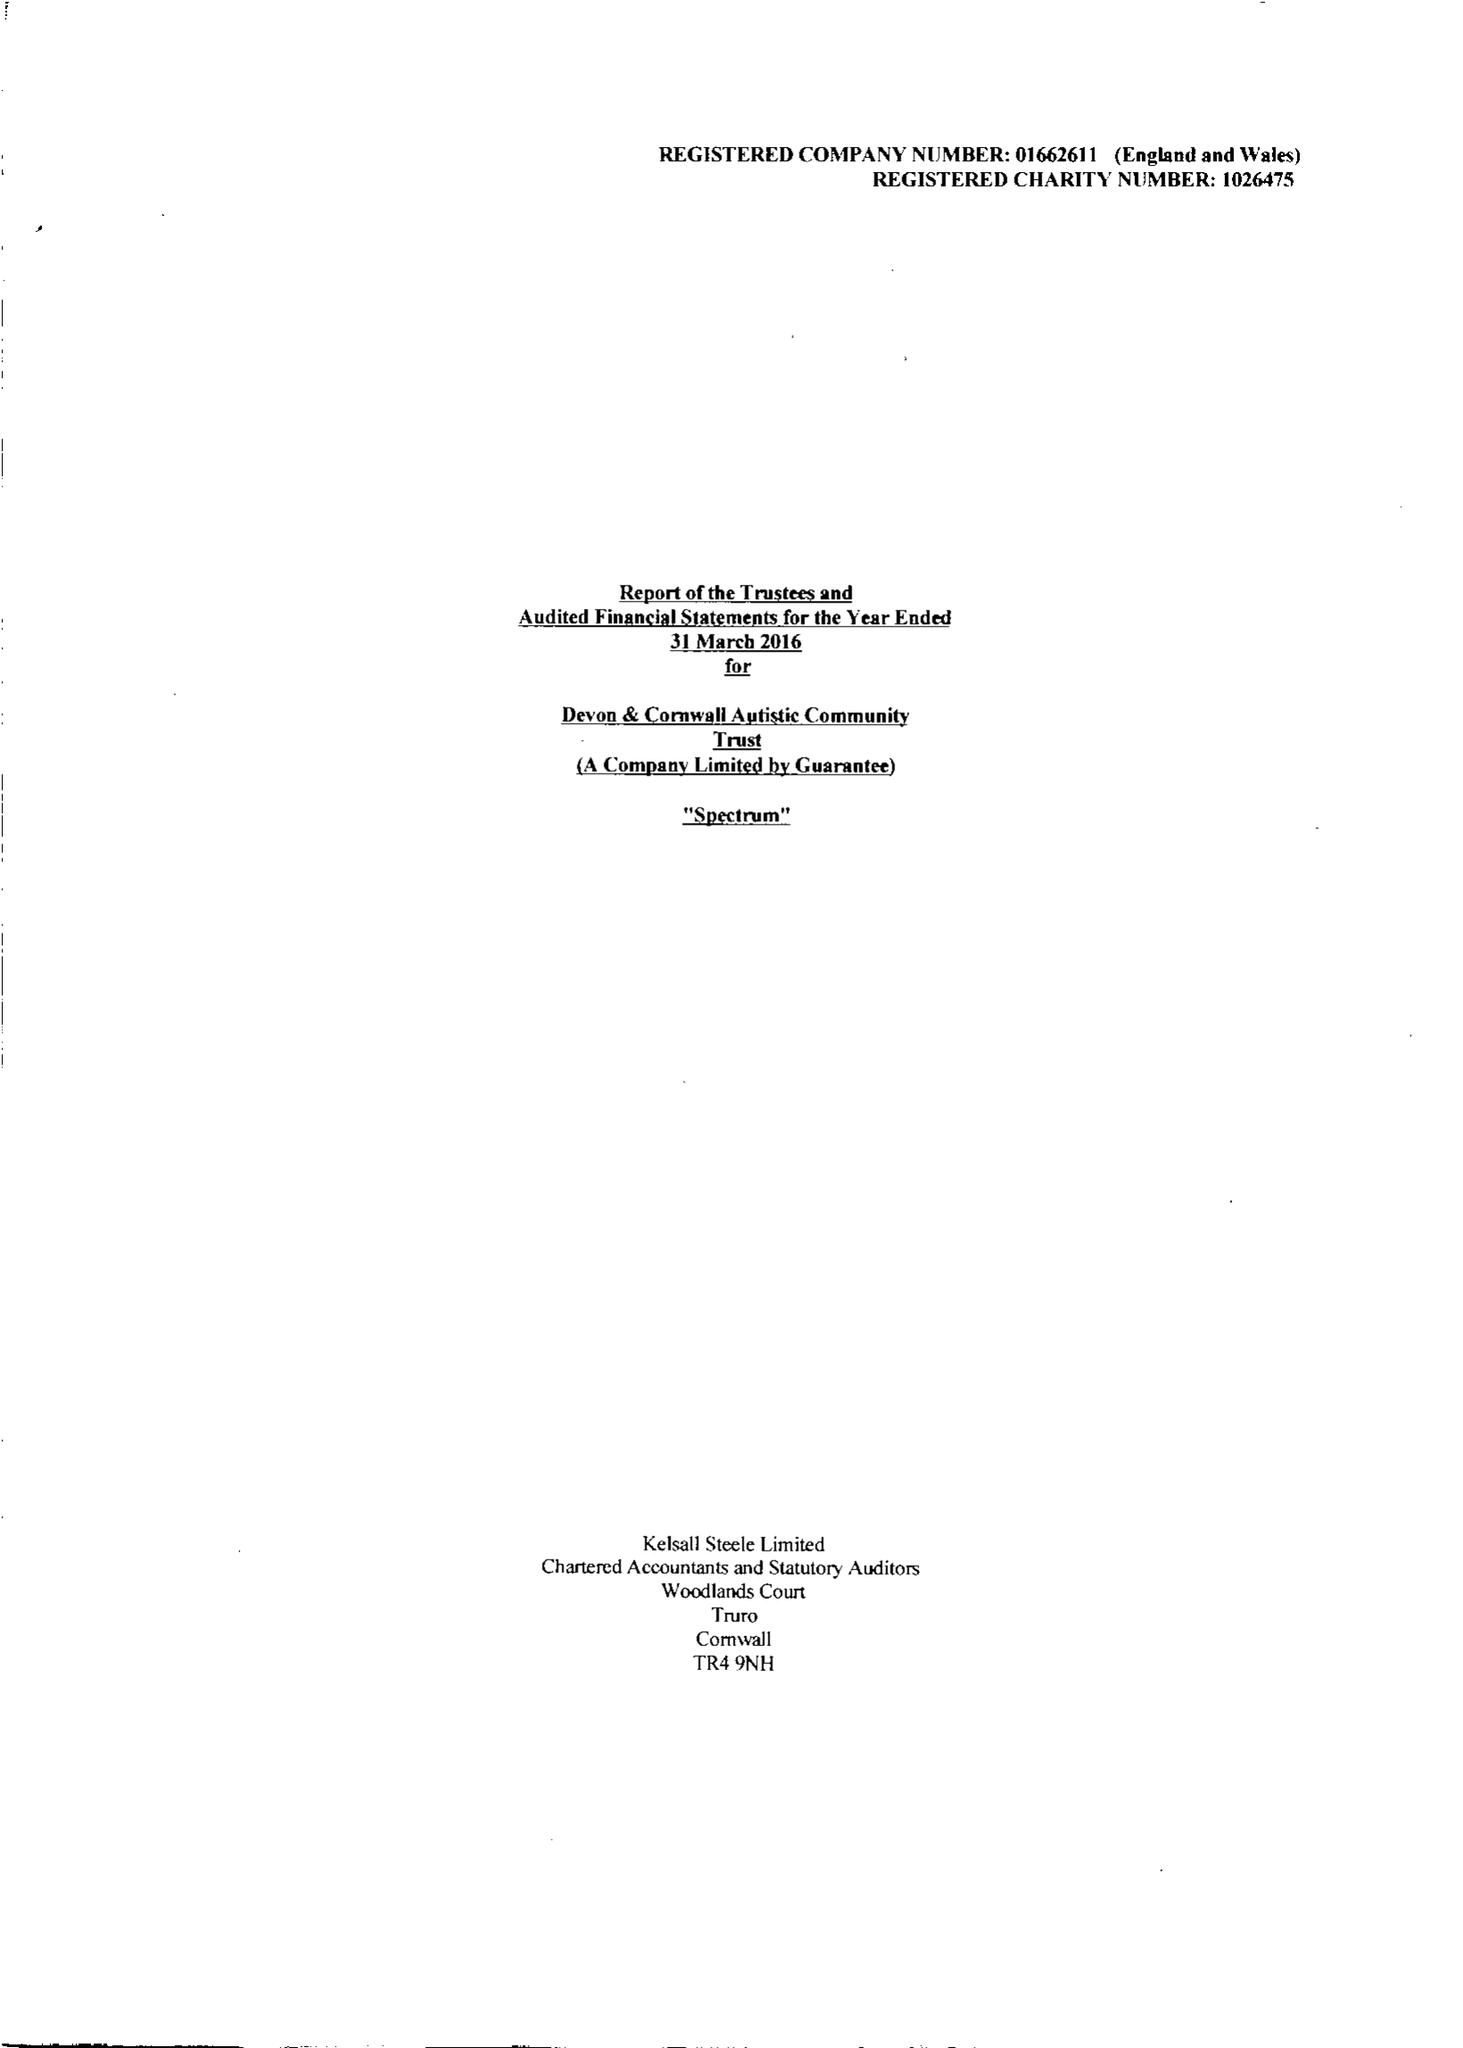What is the value for the charity_name?
Answer the question using a single word or phrase. Devon and Cornwall Autistic Community Trust 